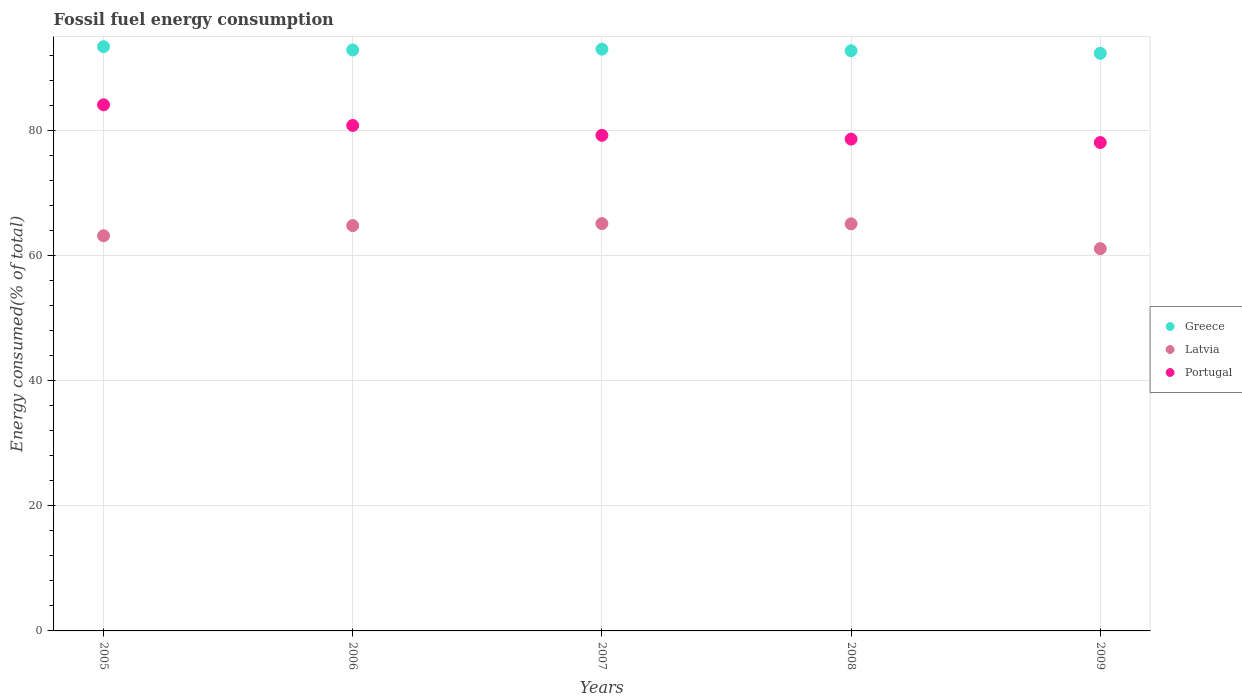How many different coloured dotlines are there?
Provide a short and direct response. 3. What is the percentage of energy consumed in Greece in 2008?
Offer a terse response. 92.77. Across all years, what is the maximum percentage of energy consumed in Latvia?
Give a very brief answer. 65.13. Across all years, what is the minimum percentage of energy consumed in Portugal?
Your answer should be very brief. 78.09. In which year was the percentage of energy consumed in Greece minimum?
Provide a short and direct response. 2009. What is the total percentage of energy consumed in Greece in the graph?
Provide a succinct answer. 464.45. What is the difference between the percentage of energy consumed in Portugal in 2005 and that in 2009?
Provide a succinct answer. 6.03. What is the difference between the percentage of energy consumed in Portugal in 2009 and the percentage of energy consumed in Latvia in 2008?
Provide a succinct answer. 13. What is the average percentage of energy consumed in Portugal per year?
Your response must be concise. 80.18. In the year 2005, what is the difference between the percentage of energy consumed in Latvia and percentage of energy consumed in Portugal?
Your answer should be very brief. -20.94. In how many years, is the percentage of energy consumed in Portugal greater than 4 %?
Offer a very short reply. 5. What is the ratio of the percentage of energy consumed in Greece in 2006 to that in 2007?
Your answer should be very brief. 1. What is the difference between the highest and the second highest percentage of energy consumed in Greece?
Keep it short and to the point. 0.4. What is the difference between the highest and the lowest percentage of energy consumed in Latvia?
Keep it short and to the point. 4. In how many years, is the percentage of energy consumed in Latvia greater than the average percentage of energy consumed in Latvia taken over all years?
Offer a very short reply. 3. Is the sum of the percentage of energy consumed in Latvia in 2005 and 2006 greater than the maximum percentage of energy consumed in Portugal across all years?
Your response must be concise. Yes. Is it the case that in every year, the sum of the percentage of energy consumed in Portugal and percentage of energy consumed in Greece  is greater than the percentage of energy consumed in Latvia?
Provide a succinct answer. Yes. Is the percentage of energy consumed in Greece strictly greater than the percentage of energy consumed in Latvia over the years?
Provide a short and direct response. Yes. Is the percentage of energy consumed in Portugal strictly less than the percentage of energy consumed in Latvia over the years?
Provide a short and direct response. No. How many dotlines are there?
Provide a short and direct response. 3. How many years are there in the graph?
Offer a terse response. 5. Are the values on the major ticks of Y-axis written in scientific E-notation?
Keep it short and to the point. No. Where does the legend appear in the graph?
Your answer should be compact. Center right. How many legend labels are there?
Your answer should be very brief. 3. How are the legend labels stacked?
Give a very brief answer. Vertical. What is the title of the graph?
Your response must be concise. Fossil fuel energy consumption. Does "Lithuania" appear as one of the legend labels in the graph?
Give a very brief answer. No. What is the label or title of the Y-axis?
Make the answer very short. Energy consumed(% of total). What is the Energy consumed(% of total) of Greece in 2005?
Provide a succinct answer. 93.42. What is the Energy consumed(% of total) of Latvia in 2005?
Make the answer very short. 63.18. What is the Energy consumed(% of total) of Portugal in 2005?
Make the answer very short. 84.12. What is the Energy consumed(% of total) of Greece in 2006?
Provide a short and direct response. 92.89. What is the Energy consumed(% of total) of Latvia in 2006?
Keep it short and to the point. 64.81. What is the Energy consumed(% of total) of Portugal in 2006?
Provide a succinct answer. 80.82. What is the Energy consumed(% of total) in Greece in 2007?
Ensure brevity in your answer.  93.02. What is the Energy consumed(% of total) of Latvia in 2007?
Provide a short and direct response. 65.13. What is the Energy consumed(% of total) of Portugal in 2007?
Offer a very short reply. 79.24. What is the Energy consumed(% of total) in Greece in 2008?
Offer a very short reply. 92.77. What is the Energy consumed(% of total) of Latvia in 2008?
Your answer should be very brief. 65.09. What is the Energy consumed(% of total) in Portugal in 2008?
Your response must be concise. 78.64. What is the Energy consumed(% of total) of Greece in 2009?
Provide a short and direct response. 92.36. What is the Energy consumed(% of total) in Latvia in 2009?
Offer a terse response. 61.13. What is the Energy consumed(% of total) in Portugal in 2009?
Ensure brevity in your answer.  78.09. Across all years, what is the maximum Energy consumed(% of total) of Greece?
Make the answer very short. 93.42. Across all years, what is the maximum Energy consumed(% of total) of Latvia?
Give a very brief answer. 65.13. Across all years, what is the maximum Energy consumed(% of total) in Portugal?
Provide a short and direct response. 84.12. Across all years, what is the minimum Energy consumed(% of total) in Greece?
Your answer should be compact. 92.36. Across all years, what is the minimum Energy consumed(% of total) in Latvia?
Give a very brief answer. 61.13. Across all years, what is the minimum Energy consumed(% of total) of Portugal?
Offer a very short reply. 78.09. What is the total Energy consumed(% of total) of Greece in the graph?
Keep it short and to the point. 464.45. What is the total Energy consumed(% of total) of Latvia in the graph?
Your answer should be very brief. 319.33. What is the total Energy consumed(% of total) of Portugal in the graph?
Your answer should be compact. 400.9. What is the difference between the Energy consumed(% of total) of Greece in 2005 and that in 2006?
Give a very brief answer. 0.52. What is the difference between the Energy consumed(% of total) of Latvia in 2005 and that in 2006?
Provide a succinct answer. -1.63. What is the difference between the Energy consumed(% of total) in Portugal in 2005 and that in 2006?
Provide a short and direct response. 3.31. What is the difference between the Energy consumed(% of total) in Greece in 2005 and that in 2007?
Provide a succinct answer. 0.4. What is the difference between the Energy consumed(% of total) in Latvia in 2005 and that in 2007?
Offer a terse response. -1.95. What is the difference between the Energy consumed(% of total) of Portugal in 2005 and that in 2007?
Your response must be concise. 4.88. What is the difference between the Energy consumed(% of total) in Greece in 2005 and that in 2008?
Provide a succinct answer. 0.65. What is the difference between the Energy consumed(% of total) in Latvia in 2005 and that in 2008?
Your response must be concise. -1.91. What is the difference between the Energy consumed(% of total) of Portugal in 2005 and that in 2008?
Your response must be concise. 5.49. What is the difference between the Energy consumed(% of total) in Greece in 2005 and that in 2009?
Your answer should be compact. 1.06. What is the difference between the Energy consumed(% of total) in Latvia in 2005 and that in 2009?
Provide a short and direct response. 2.06. What is the difference between the Energy consumed(% of total) in Portugal in 2005 and that in 2009?
Make the answer very short. 6.03. What is the difference between the Energy consumed(% of total) in Greece in 2006 and that in 2007?
Offer a terse response. -0.13. What is the difference between the Energy consumed(% of total) of Latvia in 2006 and that in 2007?
Keep it short and to the point. -0.32. What is the difference between the Energy consumed(% of total) in Portugal in 2006 and that in 2007?
Offer a very short reply. 1.58. What is the difference between the Energy consumed(% of total) in Greece in 2006 and that in 2008?
Provide a short and direct response. 0.13. What is the difference between the Energy consumed(% of total) of Latvia in 2006 and that in 2008?
Your answer should be very brief. -0.28. What is the difference between the Energy consumed(% of total) of Portugal in 2006 and that in 2008?
Provide a short and direct response. 2.18. What is the difference between the Energy consumed(% of total) in Greece in 2006 and that in 2009?
Offer a terse response. 0.54. What is the difference between the Energy consumed(% of total) in Latvia in 2006 and that in 2009?
Offer a very short reply. 3.68. What is the difference between the Energy consumed(% of total) in Portugal in 2006 and that in 2009?
Your answer should be compact. 2.73. What is the difference between the Energy consumed(% of total) in Greece in 2007 and that in 2008?
Your answer should be compact. 0.25. What is the difference between the Energy consumed(% of total) of Latvia in 2007 and that in 2008?
Ensure brevity in your answer.  0.04. What is the difference between the Energy consumed(% of total) in Portugal in 2007 and that in 2008?
Your answer should be compact. 0.6. What is the difference between the Energy consumed(% of total) of Greece in 2007 and that in 2009?
Ensure brevity in your answer.  0.66. What is the difference between the Energy consumed(% of total) of Latvia in 2007 and that in 2009?
Provide a short and direct response. 4. What is the difference between the Energy consumed(% of total) of Portugal in 2007 and that in 2009?
Keep it short and to the point. 1.15. What is the difference between the Energy consumed(% of total) in Greece in 2008 and that in 2009?
Your response must be concise. 0.41. What is the difference between the Energy consumed(% of total) in Latvia in 2008 and that in 2009?
Offer a terse response. 3.96. What is the difference between the Energy consumed(% of total) of Portugal in 2008 and that in 2009?
Your answer should be compact. 0.55. What is the difference between the Energy consumed(% of total) of Greece in 2005 and the Energy consumed(% of total) of Latvia in 2006?
Ensure brevity in your answer.  28.61. What is the difference between the Energy consumed(% of total) in Greece in 2005 and the Energy consumed(% of total) in Portugal in 2006?
Make the answer very short. 12.6. What is the difference between the Energy consumed(% of total) in Latvia in 2005 and the Energy consumed(% of total) in Portugal in 2006?
Offer a very short reply. -17.63. What is the difference between the Energy consumed(% of total) of Greece in 2005 and the Energy consumed(% of total) of Latvia in 2007?
Your response must be concise. 28.29. What is the difference between the Energy consumed(% of total) in Greece in 2005 and the Energy consumed(% of total) in Portugal in 2007?
Keep it short and to the point. 14.18. What is the difference between the Energy consumed(% of total) of Latvia in 2005 and the Energy consumed(% of total) of Portugal in 2007?
Your response must be concise. -16.06. What is the difference between the Energy consumed(% of total) of Greece in 2005 and the Energy consumed(% of total) of Latvia in 2008?
Keep it short and to the point. 28.33. What is the difference between the Energy consumed(% of total) in Greece in 2005 and the Energy consumed(% of total) in Portugal in 2008?
Provide a short and direct response. 14.78. What is the difference between the Energy consumed(% of total) in Latvia in 2005 and the Energy consumed(% of total) in Portugal in 2008?
Keep it short and to the point. -15.46. What is the difference between the Energy consumed(% of total) in Greece in 2005 and the Energy consumed(% of total) in Latvia in 2009?
Your answer should be compact. 32.29. What is the difference between the Energy consumed(% of total) of Greece in 2005 and the Energy consumed(% of total) of Portugal in 2009?
Offer a terse response. 15.33. What is the difference between the Energy consumed(% of total) of Latvia in 2005 and the Energy consumed(% of total) of Portugal in 2009?
Offer a very short reply. -14.91. What is the difference between the Energy consumed(% of total) in Greece in 2006 and the Energy consumed(% of total) in Latvia in 2007?
Your response must be concise. 27.76. What is the difference between the Energy consumed(% of total) of Greece in 2006 and the Energy consumed(% of total) of Portugal in 2007?
Make the answer very short. 13.65. What is the difference between the Energy consumed(% of total) of Latvia in 2006 and the Energy consumed(% of total) of Portugal in 2007?
Provide a short and direct response. -14.43. What is the difference between the Energy consumed(% of total) of Greece in 2006 and the Energy consumed(% of total) of Latvia in 2008?
Provide a short and direct response. 27.8. What is the difference between the Energy consumed(% of total) of Greece in 2006 and the Energy consumed(% of total) of Portugal in 2008?
Offer a terse response. 14.26. What is the difference between the Energy consumed(% of total) in Latvia in 2006 and the Energy consumed(% of total) in Portugal in 2008?
Offer a terse response. -13.83. What is the difference between the Energy consumed(% of total) of Greece in 2006 and the Energy consumed(% of total) of Latvia in 2009?
Offer a very short reply. 31.77. What is the difference between the Energy consumed(% of total) in Greece in 2006 and the Energy consumed(% of total) in Portugal in 2009?
Offer a terse response. 14.8. What is the difference between the Energy consumed(% of total) of Latvia in 2006 and the Energy consumed(% of total) of Portugal in 2009?
Your answer should be compact. -13.28. What is the difference between the Energy consumed(% of total) of Greece in 2007 and the Energy consumed(% of total) of Latvia in 2008?
Ensure brevity in your answer.  27.93. What is the difference between the Energy consumed(% of total) in Greece in 2007 and the Energy consumed(% of total) in Portugal in 2008?
Give a very brief answer. 14.38. What is the difference between the Energy consumed(% of total) in Latvia in 2007 and the Energy consumed(% of total) in Portugal in 2008?
Keep it short and to the point. -13.51. What is the difference between the Energy consumed(% of total) of Greece in 2007 and the Energy consumed(% of total) of Latvia in 2009?
Give a very brief answer. 31.89. What is the difference between the Energy consumed(% of total) in Greece in 2007 and the Energy consumed(% of total) in Portugal in 2009?
Your response must be concise. 14.93. What is the difference between the Energy consumed(% of total) in Latvia in 2007 and the Energy consumed(% of total) in Portugal in 2009?
Provide a short and direct response. -12.96. What is the difference between the Energy consumed(% of total) of Greece in 2008 and the Energy consumed(% of total) of Latvia in 2009?
Provide a succinct answer. 31.64. What is the difference between the Energy consumed(% of total) in Greece in 2008 and the Energy consumed(% of total) in Portugal in 2009?
Provide a short and direct response. 14.68. What is the difference between the Energy consumed(% of total) of Latvia in 2008 and the Energy consumed(% of total) of Portugal in 2009?
Your answer should be very brief. -13. What is the average Energy consumed(% of total) of Greece per year?
Offer a very short reply. 92.89. What is the average Energy consumed(% of total) in Latvia per year?
Give a very brief answer. 63.87. What is the average Energy consumed(% of total) of Portugal per year?
Your answer should be compact. 80.18. In the year 2005, what is the difference between the Energy consumed(% of total) of Greece and Energy consumed(% of total) of Latvia?
Make the answer very short. 30.24. In the year 2005, what is the difference between the Energy consumed(% of total) of Greece and Energy consumed(% of total) of Portugal?
Offer a terse response. 9.29. In the year 2005, what is the difference between the Energy consumed(% of total) in Latvia and Energy consumed(% of total) in Portugal?
Keep it short and to the point. -20.94. In the year 2006, what is the difference between the Energy consumed(% of total) of Greece and Energy consumed(% of total) of Latvia?
Offer a very short reply. 28.08. In the year 2006, what is the difference between the Energy consumed(% of total) in Greece and Energy consumed(% of total) in Portugal?
Ensure brevity in your answer.  12.08. In the year 2006, what is the difference between the Energy consumed(% of total) of Latvia and Energy consumed(% of total) of Portugal?
Your response must be concise. -16.01. In the year 2007, what is the difference between the Energy consumed(% of total) of Greece and Energy consumed(% of total) of Latvia?
Give a very brief answer. 27.89. In the year 2007, what is the difference between the Energy consumed(% of total) in Greece and Energy consumed(% of total) in Portugal?
Your answer should be very brief. 13.78. In the year 2007, what is the difference between the Energy consumed(% of total) in Latvia and Energy consumed(% of total) in Portugal?
Offer a terse response. -14.11. In the year 2008, what is the difference between the Energy consumed(% of total) of Greece and Energy consumed(% of total) of Latvia?
Keep it short and to the point. 27.68. In the year 2008, what is the difference between the Energy consumed(% of total) in Greece and Energy consumed(% of total) in Portugal?
Provide a succinct answer. 14.13. In the year 2008, what is the difference between the Energy consumed(% of total) in Latvia and Energy consumed(% of total) in Portugal?
Give a very brief answer. -13.55. In the year 2009, what is the difference between the Energy consumed(% of total) in Greece and Energy consumed(% of total) in Latvia?
Your response must be concise. 31.23. In the year 2009, what is the difference between the Energy consumed(% of total) of Greece and Energy consumed(% of total) of Portugal?
Your response must be concise. 14.27. In the year 2009, what is the difference between the Energy consumed(% of total) of Latvia and Energy consumed(% of total) of Portugal?
Your answer should be compact. -16.96. What is the ratio of the Energy consumed(% of total) of Greece in 2005 to that in 2006?
Your answer should be compact. 1.01. What is the ratio of the Energy consumed(% of total) of Latvia in 2005 to that in 2006?
Make the answer very short. 0.97. What is the ratio of the Energy consumed(% of total) of Portugal in 2005 to that in 2006?
Give a very brief answer. 1.04. What is the ratio of the Energy consumed(% of total) of Greece in 2005 to that in 2007?
Ensure brevity in your answer.  1. What is the ratio of the Energy consumed(% of total) in Latvia in 2005 to that in 2007?
Provide a succinct answer. 0.97. What is the ratio of the Energy consumed(% of total) of Portugal in 2005 to that in 2007?
Make the answer very short. 1.06. What is the ratio of the Energy consumed(% of total) of Greece in 2005 to that in 2008?
Your response must be concise. 1.01. What is the ratio of the Energy consumed(% of total) of Latvia in 2005 to that in 2008?
Make the answer very short. 0.97. What is the ratio of the Energy consumed(% of total) of Portugal in 2005 to that in 2008?
Provide a short and direct response. 1.07. What is the ratio of the Energy consumed(% of total) of Greece in 2005 to that in 2009?
Provide a succinct answer. 1.01. What is the ratio of the Energy consumed(% of total) of Latvia in 2005 to that in 2009?
Offer a very short reply. 1.03. What is the ratio of the Energy consumed(% of total) in Portugal in 2005 to that in 2009?
Keep it short and to the point. 1.08. What is the ratio of the Energy consumed(% of total) in Greece in 2006 to that in 2007?
Offer a very short reply. 1. What is the ratio of the Energy consumed(% of total) in Latvia in 2006 to that in 2007?
Keep it short and to the point. 1. What is the ratio of the Energy consumed(% of total) in Portugal in 2006 to that in 2007?
Offer a very short reply. 1.02. What is the ratio of the Energy consumed(% of total) of Greece in 2006 to that in 2008?
Offer a very short reply. 1. What is the ratio of the Energy consumed(% of total) in Latvia in 2006 to that in 2008?
Provide a succinct answer. 1. What is the ratio of the Energy consumed(% of total) in Portugal in 2006 to that in 2008?
Make the answer very short. 1.03. What is the ratio of the Energy consumed(% of total) in Latvia in 2006 to that in 2009?
Offer a very short reply. 1.06. What is the ratio of the Energy consumed(% of total) of Portugal in 2006 to that in 2009?
Your answer should be very brief. 1.03. What is the ratio of the Energy consumed(% of total) in Portugal in 2007 to that in 2008?
Provide a short and direct response. 1.01. What is the ratio of the Energy consumed(% of total) in Greece in 2007 to that in 2009?
Offer a very short reply. 1.01. What is the ratio of the Energy consumed(% of total) of Latvia in 2007 to that in 2009?
Offer a terse response. 1.07. What is the ratio of the Energy consumed(% of total) of Portugal in 2007 to that in 2009?
Your answer should be very brief. 1.01. What is the ratio of the Energy consumed(% of total) of Latvia in 2008 to that in 2009?
Ensure brevity in your answer.  1.06. What is the ratio of the Energy consumed(% of total) in Portugal in 2008 to that in 2009?
Offer a very short reply. 1.01. What is the difference between the highest and the second highest Energy consumed(% of total) in Greece?
Your answer should be compact. 0.4. What is the difference between the highest and the second highest Energy consumed(% of total) of Latvia?
Give a very brief answer. 0.04. What is the difference between the highest and the second highest Energy consumed(% of total) of Portugal?
Offer a terse response. 3.31. What is the difference between the highest and the lowest Energy consumed(% of total) of Greece?
Make the answer very short. 1.06. What is the difference between the highest and the lowest Energy consumed(% of total) of Latvia?
Your answer should be very brief. 4. What is the difference between the highest and the lowest Energy consumed(% of total) of Portugal?
Your answer should be compact. 6.03. 